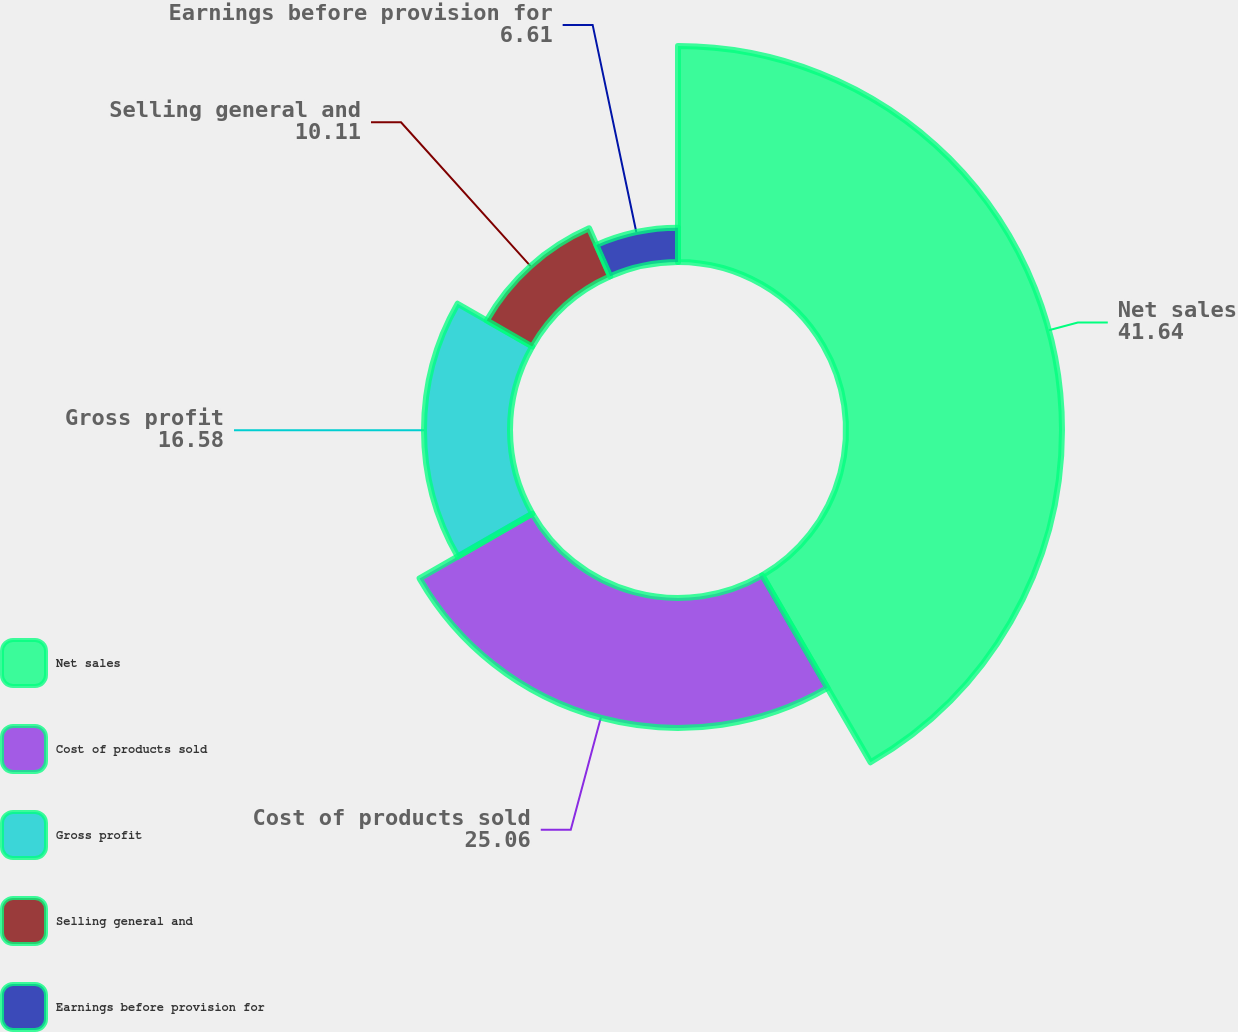Convert chart. <chart><loc_0><loc_0><loc_500><loc_500><pie_chart><fcel>Net sales<fcel>Cost of products sold<fcel>Gross profit<fcel>Selling general and<fcel>Earnings before provision for<nl><fcel>41.64%<fcel>25.06%<fcel>16.58%<fcel>10.11%<fcel>6.61%<nl></chart> 